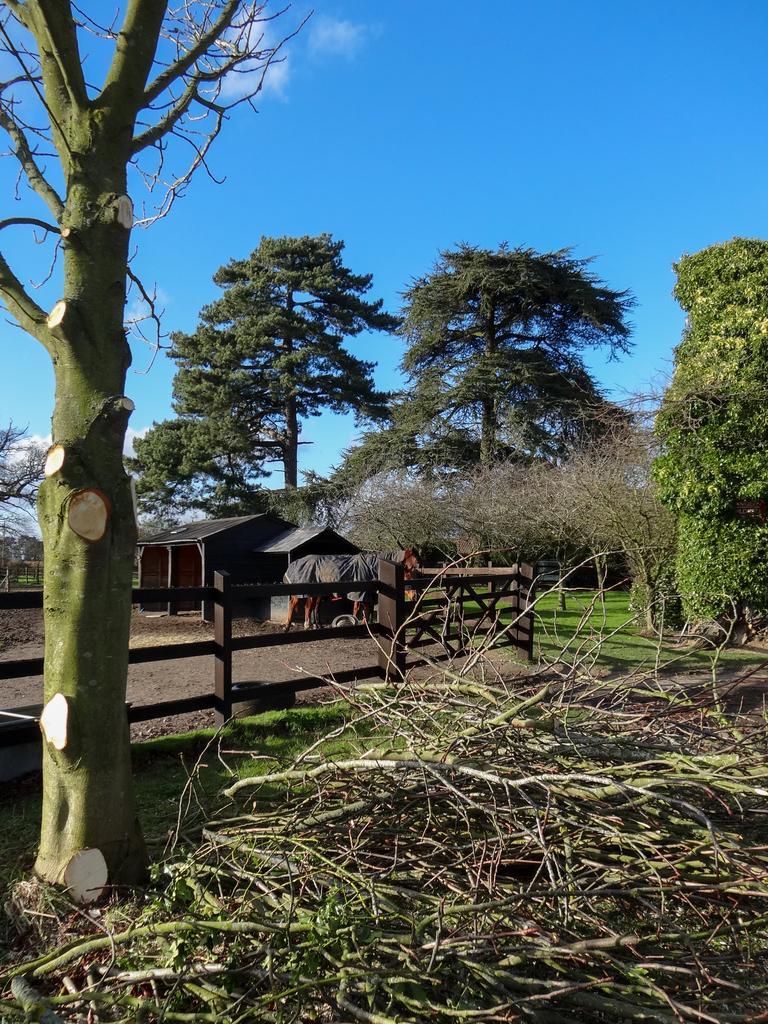What type of structure can be seen in the image? There is a fencing in the image. What is located in the middle of the image? There is a shelter in the middle of the image. What can be seen in the background of the image? There are trees in the background of the image. What color is the sky in the image? The sky is blue at the top of the image. What type of event is being represented in the image? There is no specific event being represented in the image; it simply shows a fencing, a shelter, trees, and a blue sky. Is there any paste visible in the image? There is no paste present in the image. 